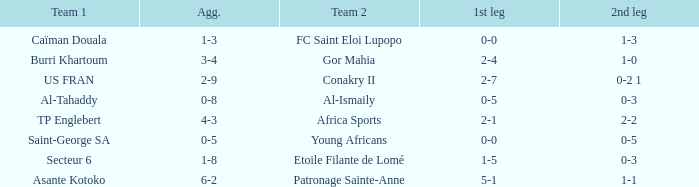Which teams had an aggregate score of 3-4? Burri Khartoum. 